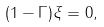<formula> <loc_0><loc_0><loc_500><loc_500>( 1 - \Gamma ) \xi = 0 ,</formula> 